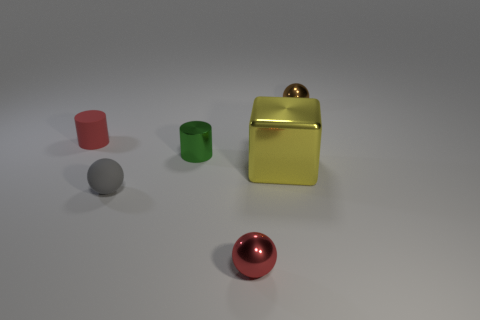There is a tiny cylinder that is in front of the tiny red object behind the big yellow metal thing; what is its color?
Give a very brief answer. Green. Do the rubber thing that is in front of the yellow metallic cube and the red object behind the tiny red metallic object have the same shape?
Make the answer very short. No. There is a gray rubber object that is the same size as the brown ball; what shape is it?
Make the answer very short. Sphere. What is the color of the small object that is made of the same material as the red cylinder?
Your answer should be compact. Gray. There is a big yellow metallic object; is it the same shape as the small red thing that is behind the large thing?
Ensure brevity in your answer.  No. There is a thing that is the same color as the matte cylinder; what is its material?
Provide a short and direct response. Metal. There is a gray thing that is the same size as the green shiny object; what is it made of?
Offer a terse response. Rubber. Is there a tiny metal object of the same color as the metal cylinder?
Ensure brevity in your answer.  No. What shape is the metallic thing that is both on the left side of the yellow thing and behind the big yellow shiny thing?
Provide a succinct answer. Cylinder. How many things have the same material as the tiny gray ball?
Keep it short and to the point. 1. 